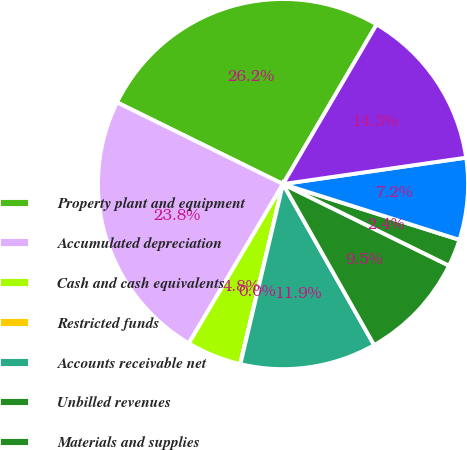Convert chart to OTSL. <chart><loc_0><loc_0><loc_500><loc_500><pie_chart><fcel>Property plant and equipment<fcel>Accumulated depreciation<fcel>Cash and cash equivalents<fcel>Restricted funds<fcel>Accounts receivable net<fcel>Unbilled revenues<fcel>Materials and supplies<fcel>Other<fcel>Total current assets<nl><fcel>26.16%<fcel>23.78%<fcel>4.78%<fcel>0.02%<fcel>11.9%<fcel>9.53%<fcel>2.4%<fcel>7.15%<fcel>14.28%<nl></chart> 